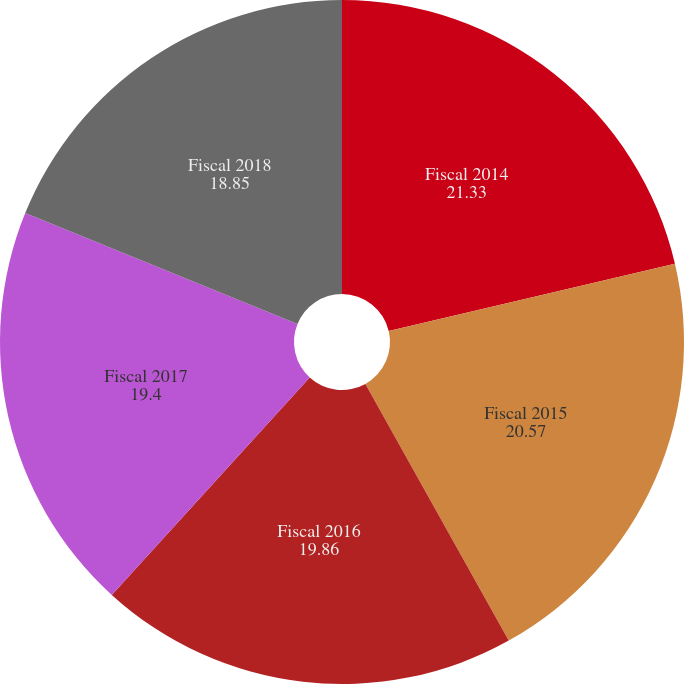Convert chart to OTSL. <chart><loc_0><loc_0><loc_500><loc_500><pie_chart><fcel>Fiscal 2014<fcel>Fiscal 2015<fcel>Fiscal 2016<fcel>Fiscal 2017<fcel>Fiscal 2018<nl><fcel>21.33%<fcel>20.57%<fcel>19.86%<fcel>19.4%<fcel>18.85%<nl></chart> 